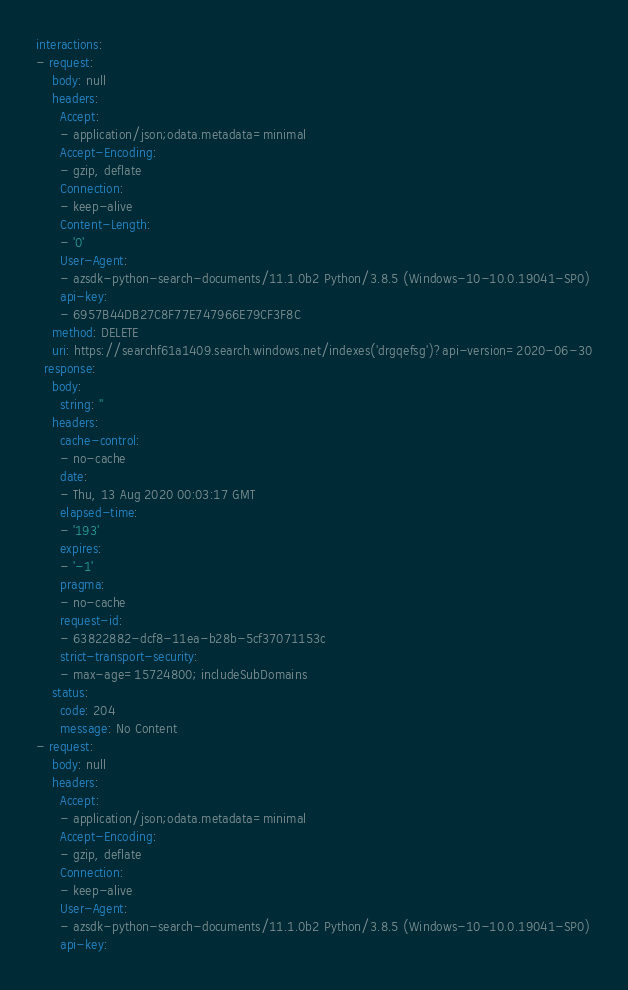<code> <loc_0><loc_0><loc_500><loc_500><_YAML_>interactions:
- request:
    body: null
    headers:
      Accept:
      - application/json;odata.metadata=minimal
      Accept-Encoding:
      - gzip, deflate
      Connection:
      - keep-alive
      Content-Length:
      - '0'
      User-Agent:
      - azsdk-python-search-documents/11.1.0b2 Python/3.8.5 (Windows-10-10.0.19041-SP0)
      api-key:
      - 6957B44DB27C8F77E747966E79CF3F8C
    method: DELETE
    uri: https://searchf61a1409.search.windows.net/indexes('drgqefsg')?api-version=2020-06-30
  response:
    body:
      string: ''
    headers:
      cache-control:
      - no-cache
      date:
      - Thu, 13 Aug 2020 00:03:17 GMT
      elapsed-time:
      - '193'
      expires:
      - '-1'
      pragma:
      - no-cache
      request-id:
      - 63822882-dcf8-11ea-b28b-5cf37071153c
      strict-transport-security:
      - max-age=15724800; includeSubDomains
    status:
      code: 204
      message: No Content
- request:
    body: null
    headers:
      Accept:
      - application/json;odata.metadata=minimal
      Accept-Encoding:
      - gzip, deflate
      Connection:
      - keep-alive
      User-Agent:
      - azsdk-python-search-documents/11.1.0b2 Python/3.8.5 (Windows-10-10.0.19041-SP0)
      api-key:</code> 